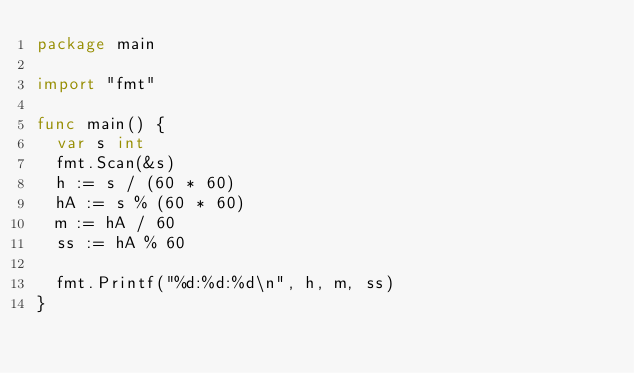<code> <loc_0><loc_0><loc_500><loc_500><_Go_>package main

import "fmt"

func main() {
	var s int
	fmt.Scan(&s)
	h := s / (60 * 60)
	hA := s % (60 * 60)
	m := hA / 60
	ss := hA % 60

	fmt.Printf("%d:%d:%d\n", h, m, ss)
}

</code> 